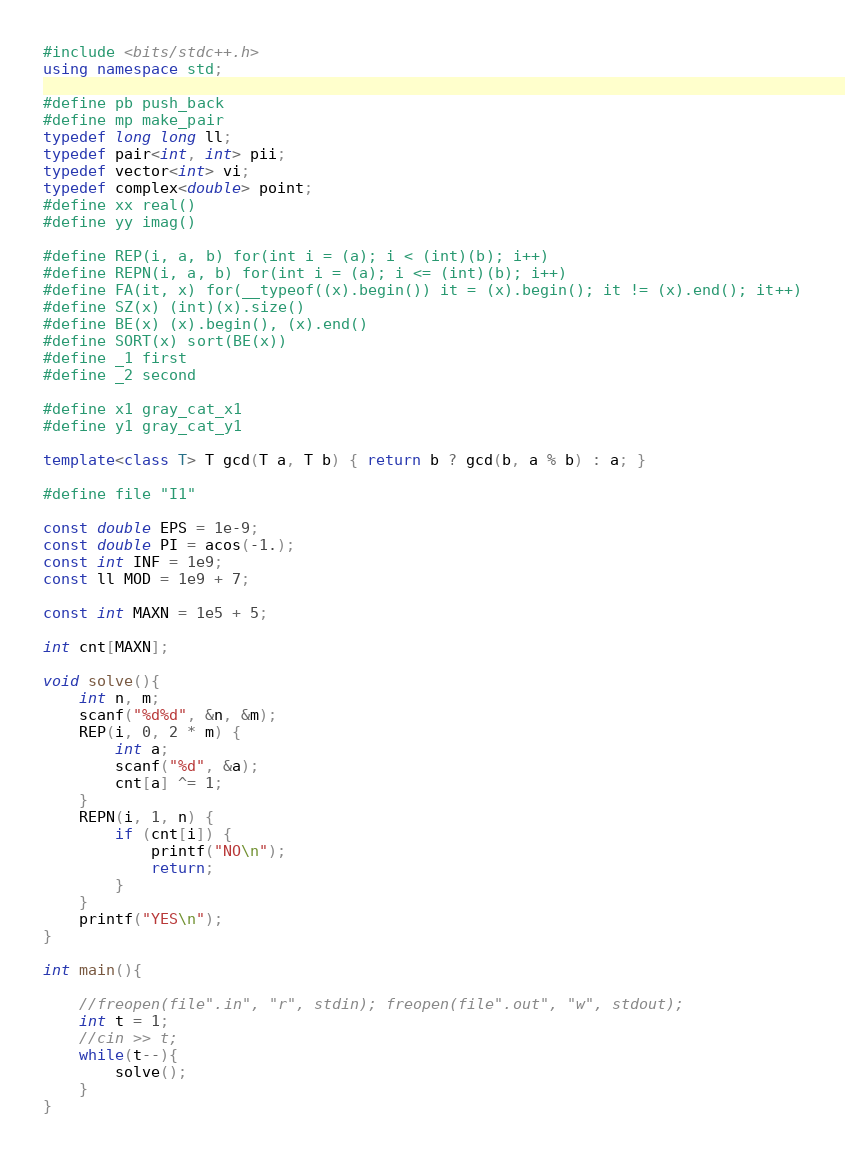Convert code to text. <code><loc_0><loc_0><loc_500><loc_500><_C++_>#include <bits/stdc++.h>
using namespace std;

#define pb push_back
#define mp make_pair
typedef long long ll;
typedef pair<int, int> pii;
typedef vector<int> vi;
typedef complex<double> point;
#define xx real()
#define yy imag()

#define REP(i, a, b) for(int i = (a); i < (int)(b); i++)
#define REPN(i, a, b) for(int i = (a); i <= (int)(b); i++)
#define FA(it, x) for(__typeof((x).begin()) it = (x).begin(); it != (x).end(); it++)
#define SZ(x) (int)(x).size()
#define BE(x) (x).begin(), (x).end()
#define SORT(x) sort(BE(x))
#define _1 first
#define _2 second

#define x1 gray_cat_x1
#define y1 gray_cat_y1

template<class T> T gcd(T a, T b) { return b ? gcd(b, a % b) : a; }

#define file "I1"

const double EPS = 1e-9;
const double PI = acos(-1.);
const int INF = 1e9;
const ll MOD = 1e9 + 7;

const int MAXN = 1e5 + 5;

int cnt[MAXN];

void solve(){
	int n, m;
	scanf("%d%d", &n, &m);
	REP(i, 0, 2 * m) {
		int a;
		scanf("%d", &a);
		cnt[a] ^= 1;
	}
	REPN(i, 1, n) {
		if (cnt[i]) {
			printf("NO\n");
			return;
		}
	}
	printf("YES\n");
}   

int main(){

    //freopen(file".in", "r", stdin); freopen(file".out", "w", stdout);
    int t = 1;
    //cin >> t;
    while(t--){
        solve();    
    }
}
</code> 